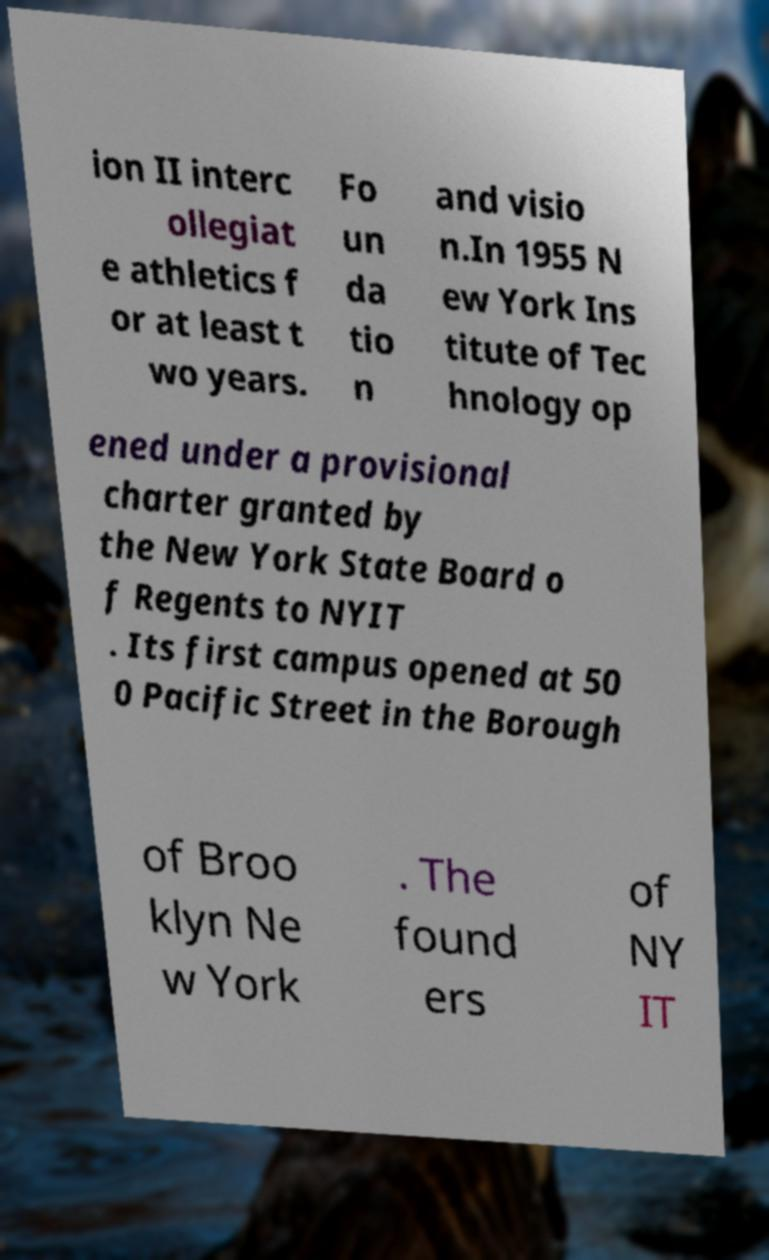I need the written content from this picture converted into text. Can you do that? ion II interc ollegiat e athletics f or at least t wo years. Fo un da tio n and visio n.In 1955 N ew York Ins titute of Tec hnology op ened under a provisional charter granted by the New York State Board o f Regents to NYIT . Its first campus opened at 50 0 Pacific Street in the Borough of Broo klyn Ne w York . The found ers of NY IT 